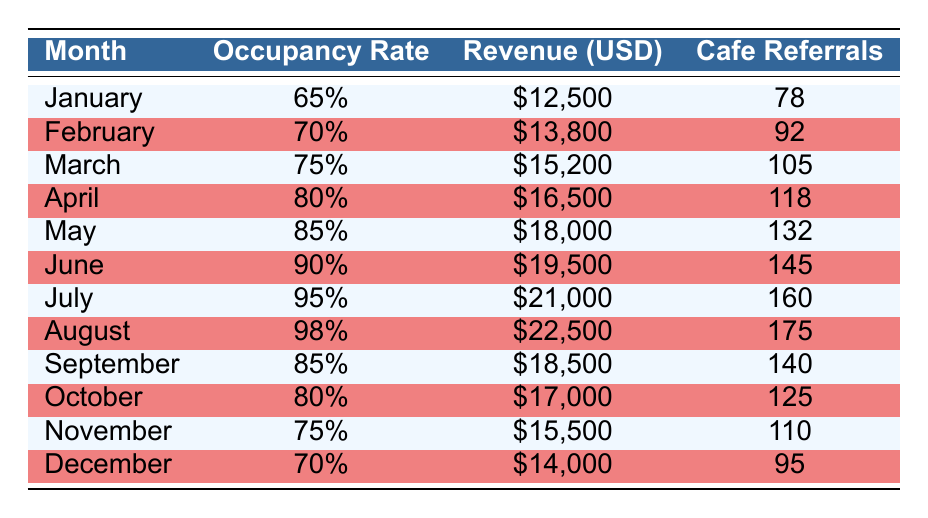What is the occupancy rate for July? The occupancy rate for July is listed directly in the table, so I can refer to the row for July to find this information.
Answer: 95% How much revenue did the hostel generate in April? Similar to the previous question, the revenue for April can be found directly in the table under the corresponding month.
Answer: $16,500 Which month had the highest number of cafe referrals? By examining the "Cafe Referrals" column, I can see the highest value occurs in August with the row indicating 175 referrals.
Answer: 175 What is the total revenue generated from May to August? To find this total, I need to sum the revenue from each of those months: $18,000 (May) + $19,500 (June) + $21,000 (July) + $22,500 (August) = $81,000.
Answer: $81,000 Is the occupancy rate in October higher than in November? I will compare the occupancy rates for October and November directly from the table. October has 80% and November has 75%, thus October is higher.
Answer: Yes What is the average occupancy rate from January to March? I need to add the occupancy rates for January (65%), February (70%), and March (75%). First, convert them to numerical values: 65 + 70 + 75 = 210. Then divide by the number of months (3): 210/3 = 70%.
Answer: 70% Did the revenue decrease from August to September? I will compare the revenue values of the two months. August revenue is $22,500 and September is $18,500. Since $22,500 is greater than $18,500, revenue did decrease.
Answer: Yes What percentage increase in revenue occurred from January to July? To calculate this percentage increase, I will find the difference between the revenue for July and January: $21,000 - $12,500 = $8,500. Then I divide the difference by the revenue in January ($12,500) and multiply by 100: ($8,500/$12,500) * 100 = 68%.
Answer: 68% What is the median occupancy rate for the entire year? To find the median occupancy rate, I will list all the occupancy rates: 65%, 70%, 75%, 80%, 85%, 90%, 95%, 98%, 85%, 80%, 75%, 70%. Sorting these gives: 65%, 70%, 70%, 75%, 75%, 80%, 80%, 85%, 85%, 90%, 95%, 98%. There are 12 values, so the median is the average of the 6th and 7th values: (80 + 85)/2 = 82.5%.
Answer: 82.5% 